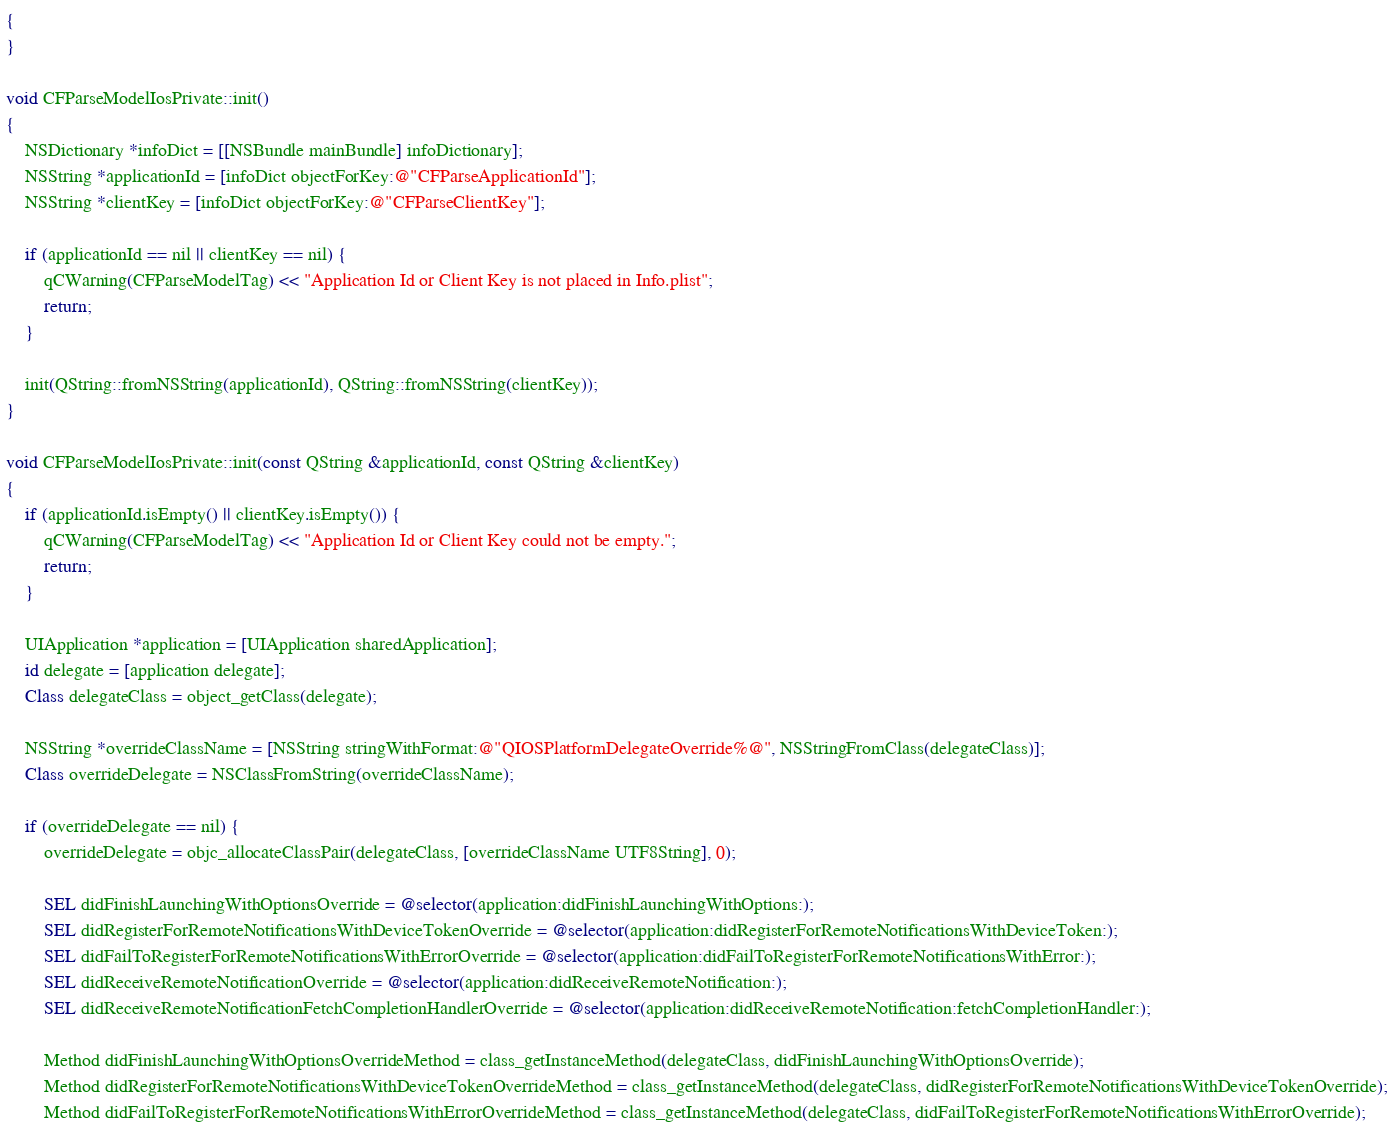<code> <loc_0><loc_0><loc_500><loc_500><_ObjectiveC_>{
}

void CFParseModelIosPrivate::init()
{
    NSDictionary *infoDict = [[NSBundle mainBundle] infoDictionary];
    NSString *applicationId = [infoDict objectForKey:@"CFParseApplicationId"];
    NSString *clientKey = [infoDict objectForKey:@"CFParseClientKey"];

    if (applicationId == nil || clientKey == nil) {
        qCWarning(CFParseModelTag) << "Application Id or Client Key is not placed in Info.plist";
        return;
    }

    init(QString::fromNSString(applicationId), QString::fromNSString(clientKey));
}

void CFParseModelIosPrivate::init(const QString &applicationId, const QString &clientKey)
{
    if (applicationId.isEmpty() || clientKey.isEmpty()) {
        qCWarning(CFParseModelTag) << "Application Id or Client Key could not be empty.";
        return;
    }

    UIApplication *application = [UIApplication sharedApplication];
    id delegate = [application delegate];
    Class delegateClass = object_getClass(delegate);

    NSString *overrideClassName = [NSString stringWithFormat:@"QIOSPlatformDelegateOverride%@", NSStringFromClass(delegateClass)];
    Class overrideDelegate = NSClassFromString(overrideClassName);

    if (overrideDelegate == nil) {
        overrideDelegate = objc_allocateClassPair(delegateClass, [overrideClassName UTF8String], 0);

        SEL didFinishLaunchingWithOptionsOverride = @selector(application:didFinishLaunchingWithOptions:);
        SEL didRegisterForRemoteNotificationsWithDeviceTokenOverride = @selector(application:didRegisterForRemoteNotificationsWithDeviceToken:);
        SEL didFailToRegisterForRemoteNotificationsWithErrorOverride = @selector(application:didFailToRegisterForRemoteNotificationsWithError:);
        SEL didReceiveRemoteNotificationOverride = @selector(application:didReceiveRemoteNotification:);
        SEL didReceiveRemoteNotificationFetchCompletionHandlerOverride = @selector(application:didReceiveRemoteNotification:fetchCompletionHandler:);

        Method didFinishLaunchingWithOptionsOverrideMethod = class_getInstanceMethod(delegateClass, didFinishLaunchingWithOptionsOverride);
        Method didRegisterForRemoteNotificationsWithDeviceTokenOverrideMethod = class_getInstanceMethod(delegateClass, didRegisterForRemoteNotificationsWithDeviceTokenOverride);
        Method didFailToRegisterForRemoteNotificationsWithErrorOverrideMethod = class_getInstanceMethod(delegateClass, didFailToRegisterForRemoteNotificationsWithErrorOverride);</code> 